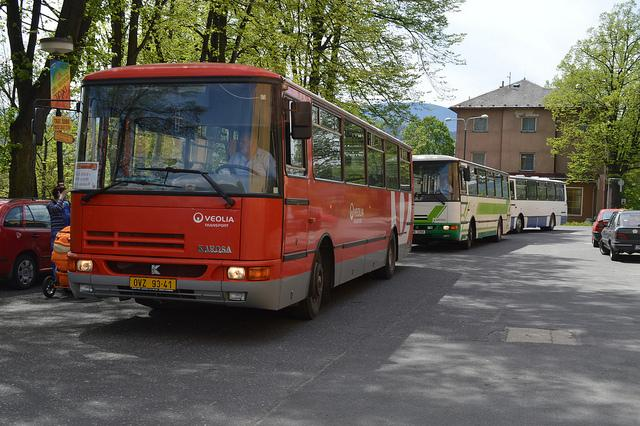Why are the buses lined up?

Choices:
A) awaiting passengers
B) racing
C) heavy traffic
D) are lost awaiting passengers 